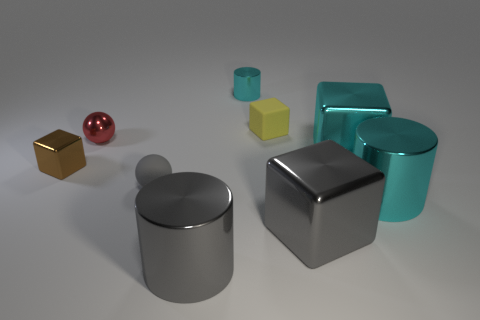Subtract all big cyan metallic blocks. How many blocks are left? 3 Subtract all gray cubes. How many cubes are left? 3 Subtract all purple blocks. Subtract all red balls. How many blocks are left? 4 Add 1 metallic cylinders. How many objects exist? 10 Subtract all blocks. How many objects are left? 5 Add 7 gray rubber objects. How many gray rubber objects exist? 8 Subtract 1 gray spheres. How many objects are left? 8 Subtract all metal things. Subtract all tiny green rubber balls. How many objects are left? 2 Add 2 tiny metal things. How many tiny metal things are left? 5 